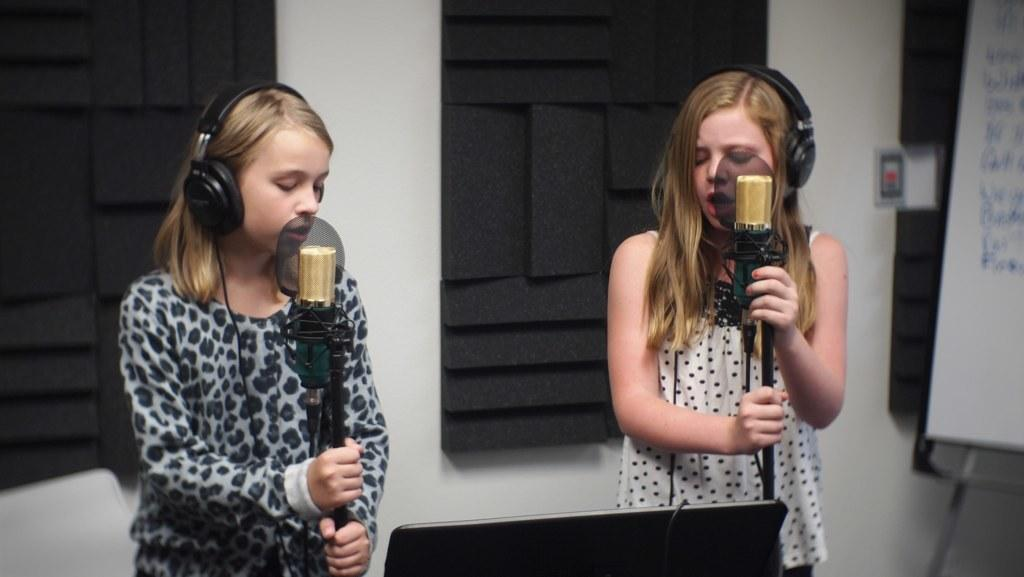How many people are in the image? There are two girls in the image. What are the girls doing in the image? The girls are singing in the image. What tools are the girls using while singing? The girls are using microphones in the image. What are the girls wearing on their ears? The girls are wearing headphones over their ears in the image. What can be seen in the background of the image? There is a wall and a notice board in the background of the image. What type of map can be seen on the wall in the image? There is no map present in the image; only a wall and a notice board can be seen in the background. 